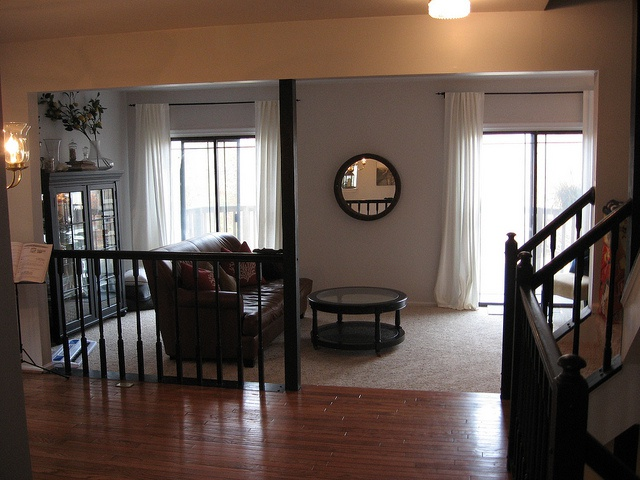Describe the objects in this image and their specific colors. I can see couch in maroon, black, gray, and darkgray tones, dining table in maroon, black, and gray tones, book in maroon, brown, and black tones, vase in maroon, gray, and black tones, and vase in maroon, gray, and black tones in this image. 